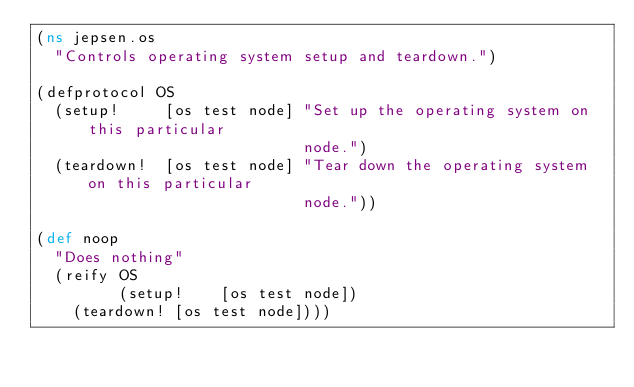<code> <loc_0><loc_0><loc_500><loc_500><_Clojure_>(ns jepsen.os
  "Controls operating system setup and teardown.")

(defprotocol OS
  (setup!     [os test node] "Set up the operating system on this particular
                             node.")
  (teardown!  [os test node] "Tear down the operating system on this particular
                             node."))

(def noop
  "Does nothing"
  (reify OS
         (setup!    [os test node])
    (teardown! [os test node])))
</code> 